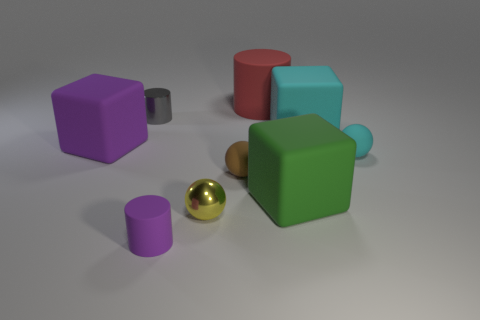Subtract all small brown matte spheres. How many spheres are left? 2 Subtract 1 cubes. How many cubes are left? 2 Add 1 brown things. How many objects exist? 10 Subtract all red spheres. Subtract all purple cylinders. How many spheres are left? 3 Subtract all balls. How many objects are left? 6 Subtract all large blue rubber balls. Subtract all purple cylinders. How many objects are left? 8 Add 7 yellow shiny balls. How many yellow shiny balls are left? 8 Add 5 purple blocks. How many purple blocks exist? 6 Subtract 0 gray balls. How many objects are left? 9 